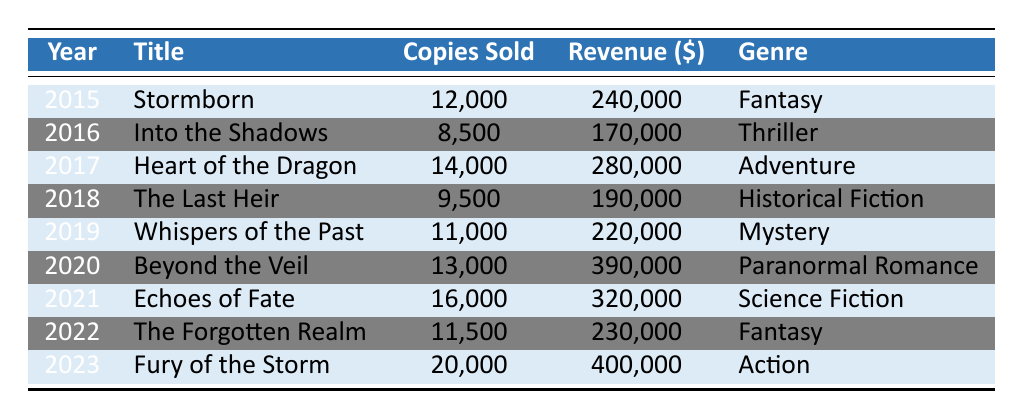What was the best-selling book of Randy Lindsay from 2015 to 2023? By looking at the "Copies Sold" column, the book with the highest number of copies sold is "Fury of the Storm" from the year 2023, with 20,000 copies sold.
Answer: Fury of the Storm What was the total revenue generated from Randy Lindsay's books in 2019 and 2020? To find the total revenue, we add the revenue from both years: 220,000 (2019) + 390,000 (2020) = 610,000.
Answer: 610,000 Did "Into the Shadows" sell more than "The Last Heir"? "Into the Shadows" sold 8,500 copies, while "The Last Heir" sold 9,500 copies. Since 8,500 is less than 9,500, the statement is false.
Answer: No How many total copies of Randy Lindsay’s books were sold from 2015 to 2023? We sum the copies sold for each year: 12,000 + 8,500 + 14,000 + 9,500 + 11,000 + 13,000 + 16,000 + 11,500 + 20,000 =  125,500.
Answer: 125,500 What was the average revenue of the books released in the years 2017, 2021, and 2023? We first find the total revenue for these years: 280,000 (2017) + 320,000 (2021) + 400,000 (2023) = 1,000,000. Then we divide this by the number of books: 1,000,000 / 3 = 333,333.33.
Answer: 333,333.33 Was there a genre that generated more than 400,000 in revenue in any given year? Looking through the table, only "Fury of the Storm" generated 400,000 in 2023, which is not more than 400,000. Therefore, the statement is false.
Answer: No 